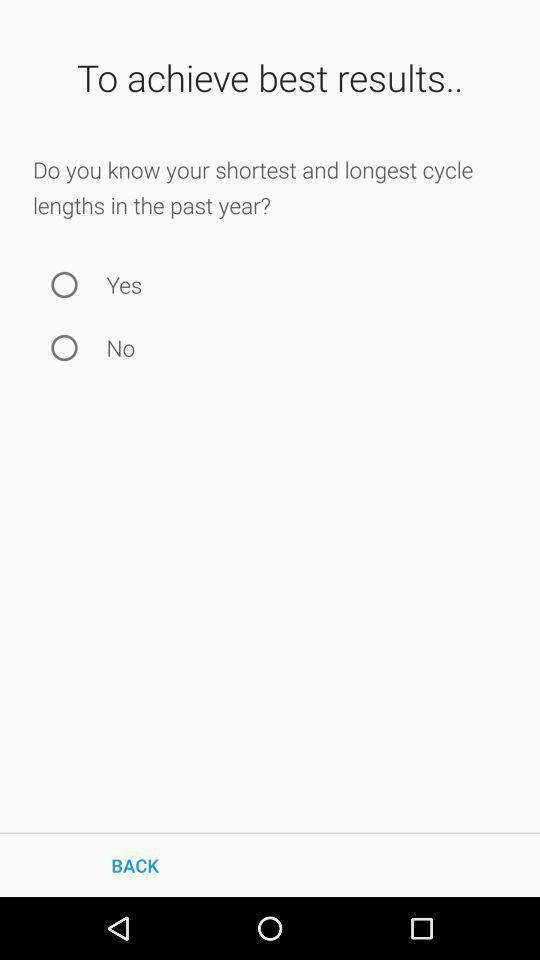Give me a summary of this screen capture. Screen shows about period tracker application. 